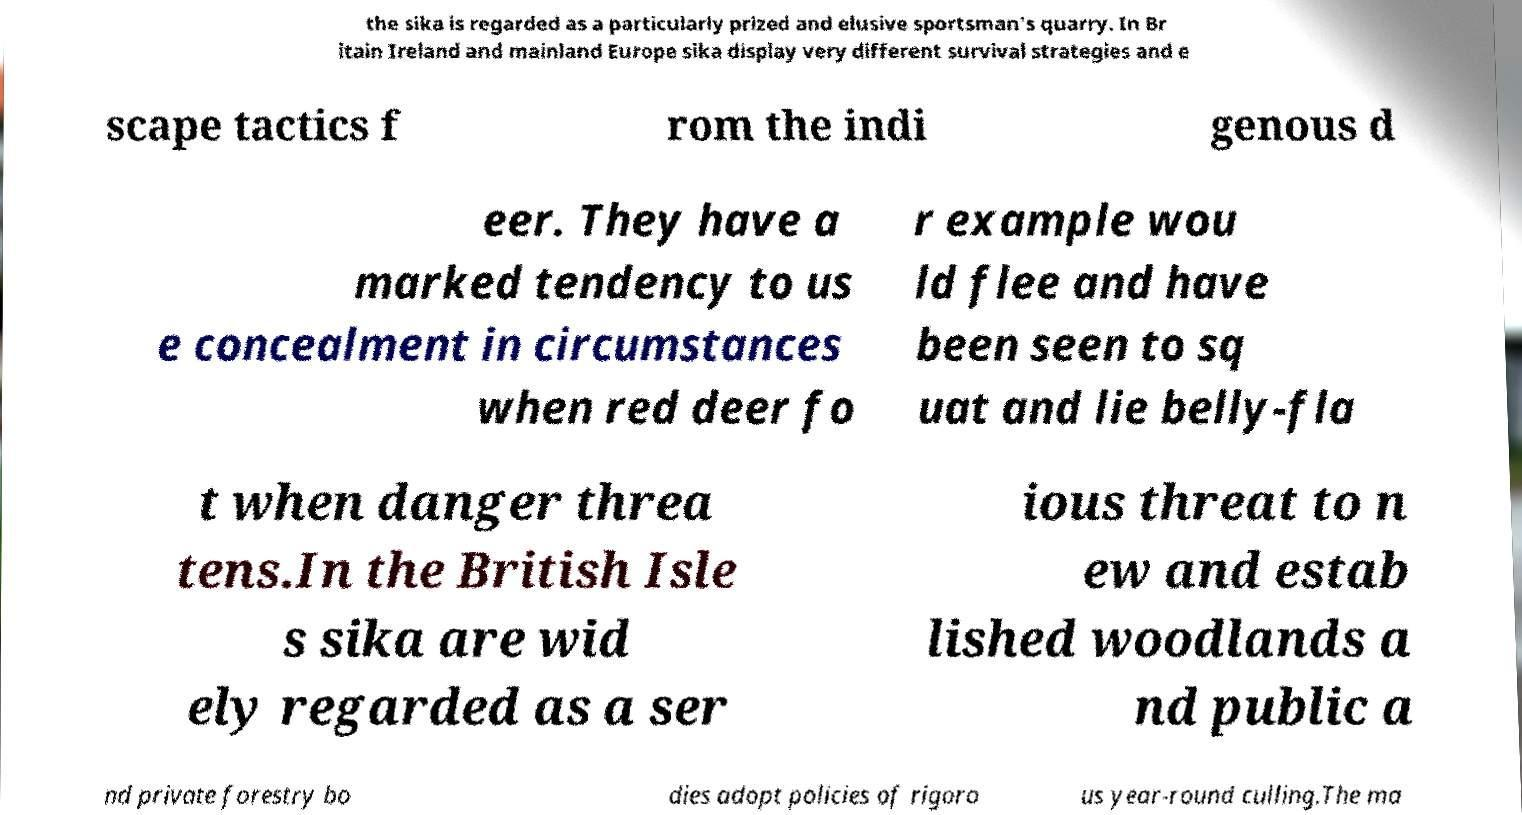Please identify and transcribe the text found in this image. the sika is regarded as a particularly prized and elusive sportsman's quarry. In Br itain Ireland and mainland Europe sika display very different survival strategies and e scape tactics f rom the indi genous d eer. They have a marked tendency to us e concealment in circumstances when red deer fo r example wou ld flee and have been seen to sq uat and lie belly-fla t when danger threa tens.In the British Isle s sika are wid ely regarded as a ser ious threat to n ew and estab lished woodlands a nd public a nd private forestry bo dies adopt policies of rigoro us year-round culling.The ma 